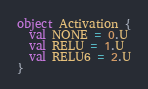Convert code to text. <code><loc_0><loc_0><loc_500><loc_500><_Scala_>
object Activation {
  val NONE = 0.U
  val RELU = 1.U
  val RELU6 = 2.U
}
</code> 